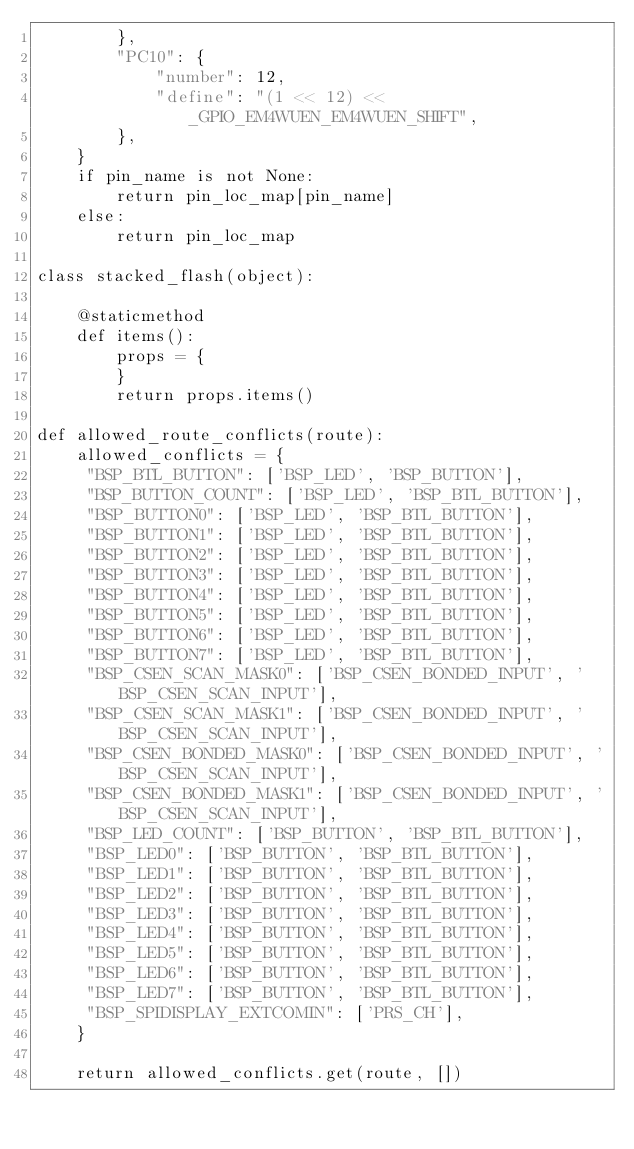Convert code to text. <code><loc_0><loc_0><loc_500><loc_500><_Python_>        },
        "PC10": {
            "number": 12,
            "define": "(1 << 12) << _GPIO_EM4WUEN_EM4WUEN_SHIFT",
        },
    }
    if pin_name is not None:
        return pin_loc_map[pin_name]
    else:
        return pin_loc_map

class stacked_flash(object):
    
    @staticmethod
    def items():
        props = {
        }
        return props.items()

def allowed_route_conflicts(route):
    allowed_conflicts = {
     "BSP_BTL_BUTTON": ['BSP_LED', 'BSP_BUTTON'],
     "BSP_BUTTON_COUNT": ['BSP_LED', 'BSP_BTL_BUTTON'],
     "BSP_BUTTON0": ['BSP_LED', 'BSP_BTL_BUTTON'],
     "BSP_BUTTON1": ['BSP_LED', 'BSP_BTL_BUTTON'],
     "BSP_BUTTON2": ['BSP_LED', 'BSP_BTL_BUTTON'],
     "BSP_BUTTON3": ['BSP_LED', 'BSP_BTL_BUTTON'],
     "BSP_BUTTON4": ['BSP_LED', 'BSP_BTL_BUTTON'],
     "BSP_BUTTON5": ['BSP_LED', 'BSP_BTL_BUTTON'],
     "BSP_BUTTON6": ['BSP_LED', 'BSP_BTL_BUTTON'],
     "BSP_BUTTON7": ['BSP_LED', 'BSP_BTL_BUTTON'],
     "BSP_CSEN_SCAN_MASK0": ['BSP_CSEN_BONDED_INPUT', 'BSP_CSEN_SCAN_INPUT'],
     "BSP_CSEN_SCAN_MASK1": ['BSP_CSEN_BONDED_INPUT', 'BSP_CSEN_SCAN_INPUT'],
     "BSP_CSEN_BONDED_MASK0": ['BSP_CSEN_BONDED_INPUT', 'BSP_CSEN_SCAN_INPUT'],
     "BSP_CSEN_BONDED_MASK1": ['BSP_CSEN_BONDED_INPUT', 'BSP_CSEN_SCAN_INPUT'],
     "BSP_LED_COUNT": ['BSP_BUTTON', 'BSP_BTL_BUTTON'],
     "BSP_LED0": ['BSP_BUTTON', 'BSP_BTL_BUTTON'],
     "BSP_LED1": ['BSP_BUTTON', 'BSP_BTL_BUTTON'],
     "BSP_LED2": ['BSP_BUTTON', 'BSP_BTL_BUTTON'],
     "BSP_LED3": ['BSP_BUTTON', 'BSP_BTL_BUTTON'],
     "BSP_LED4": ['BSP_BUTTON', 'BSP_BTL_BUTTON'],
     "BSP_LED5": ['BSP_BUTTON', 'BSP_BTL_BUTTON'],
     "BSP_LED6": ['BSP_BUTTON', 'BSP_BTL_BUTTON'],
     "BSP_LED7": ['BSP_BUTTON', 'BSP_BTL_BUTTON'],
     "BSP_SPIDISPLAY_EXTCOMIN": ['PRS_CH'],
    }

    return allowed_conflicts.get(route, [])</code> 